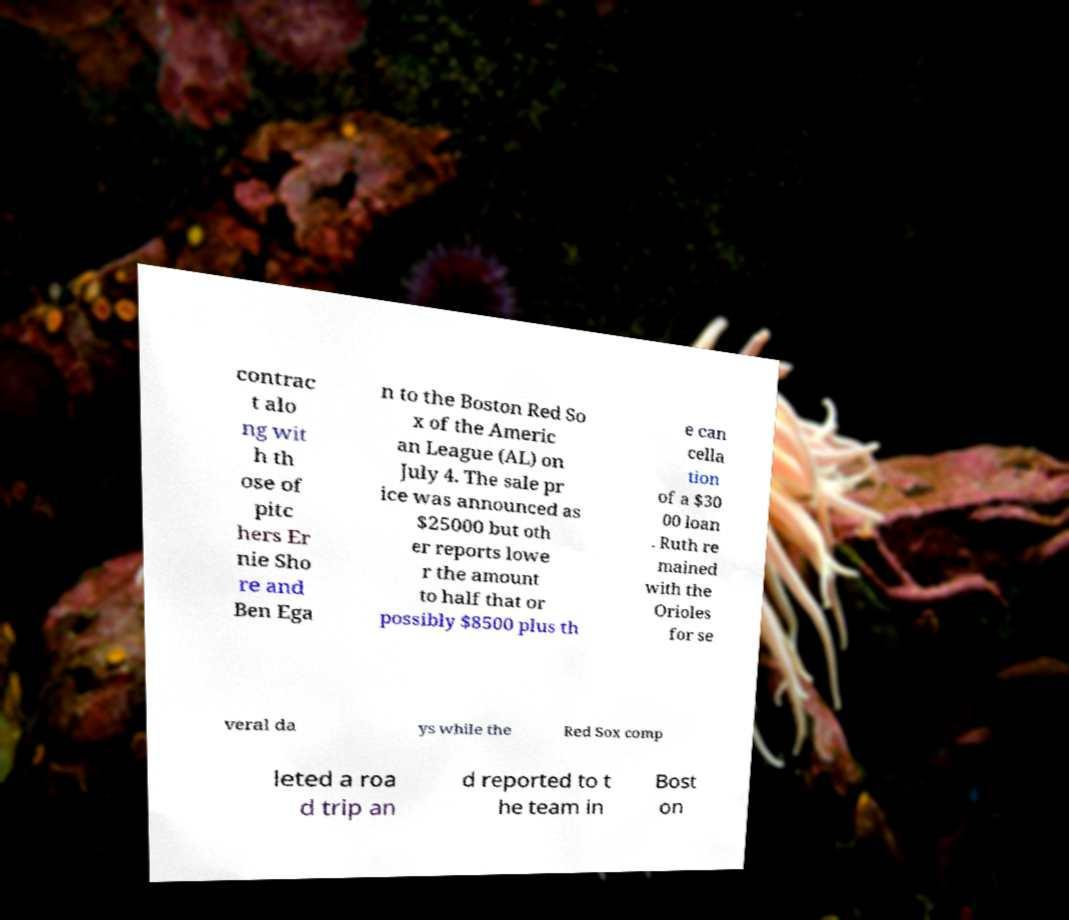For documentation purposes, I need the text within this image transcribed. Could you provide that? contrac t alo ng wit h th ose of pitc hers Er nie Sho re and Ben Ega n to the Boston Red So x of the Americ an League (AL) on July 4. The sale pr ice was announced as $25000 but oth er reports lowe r the amount to half that or possibly $8500 plus th e can cella tion of a $30 00 loan . Ruth re mained with the Orioles for se veral da ys while the Red Sox comp leted a roa d trip an d reported to t he team in Bost on 